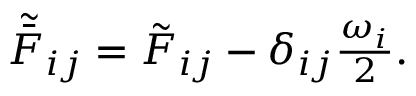<formula> <loc_0><loc_0><loc_500><loc_500>\begin{array} { r } { \tilde { \bar { F } } _ { i j } = \tilde { F } _ { i j } - \delta _ { i j } \frac { \omega _ { i } } { 2 } . } \end{array}</formula> 